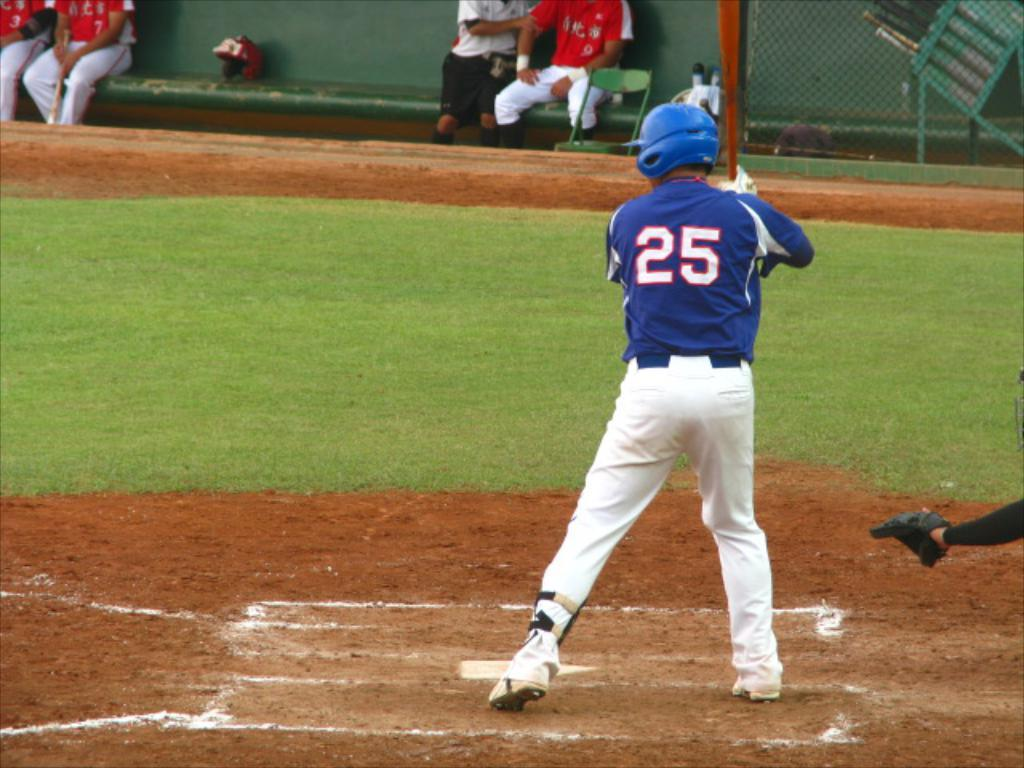<image>
Relay a brief, clear account of the picture shown. Number 25 is at home base about to swing his bat. 